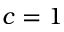<formula> <loc_0><loc_0><loc_500><loc_500>c = 1</formula> 